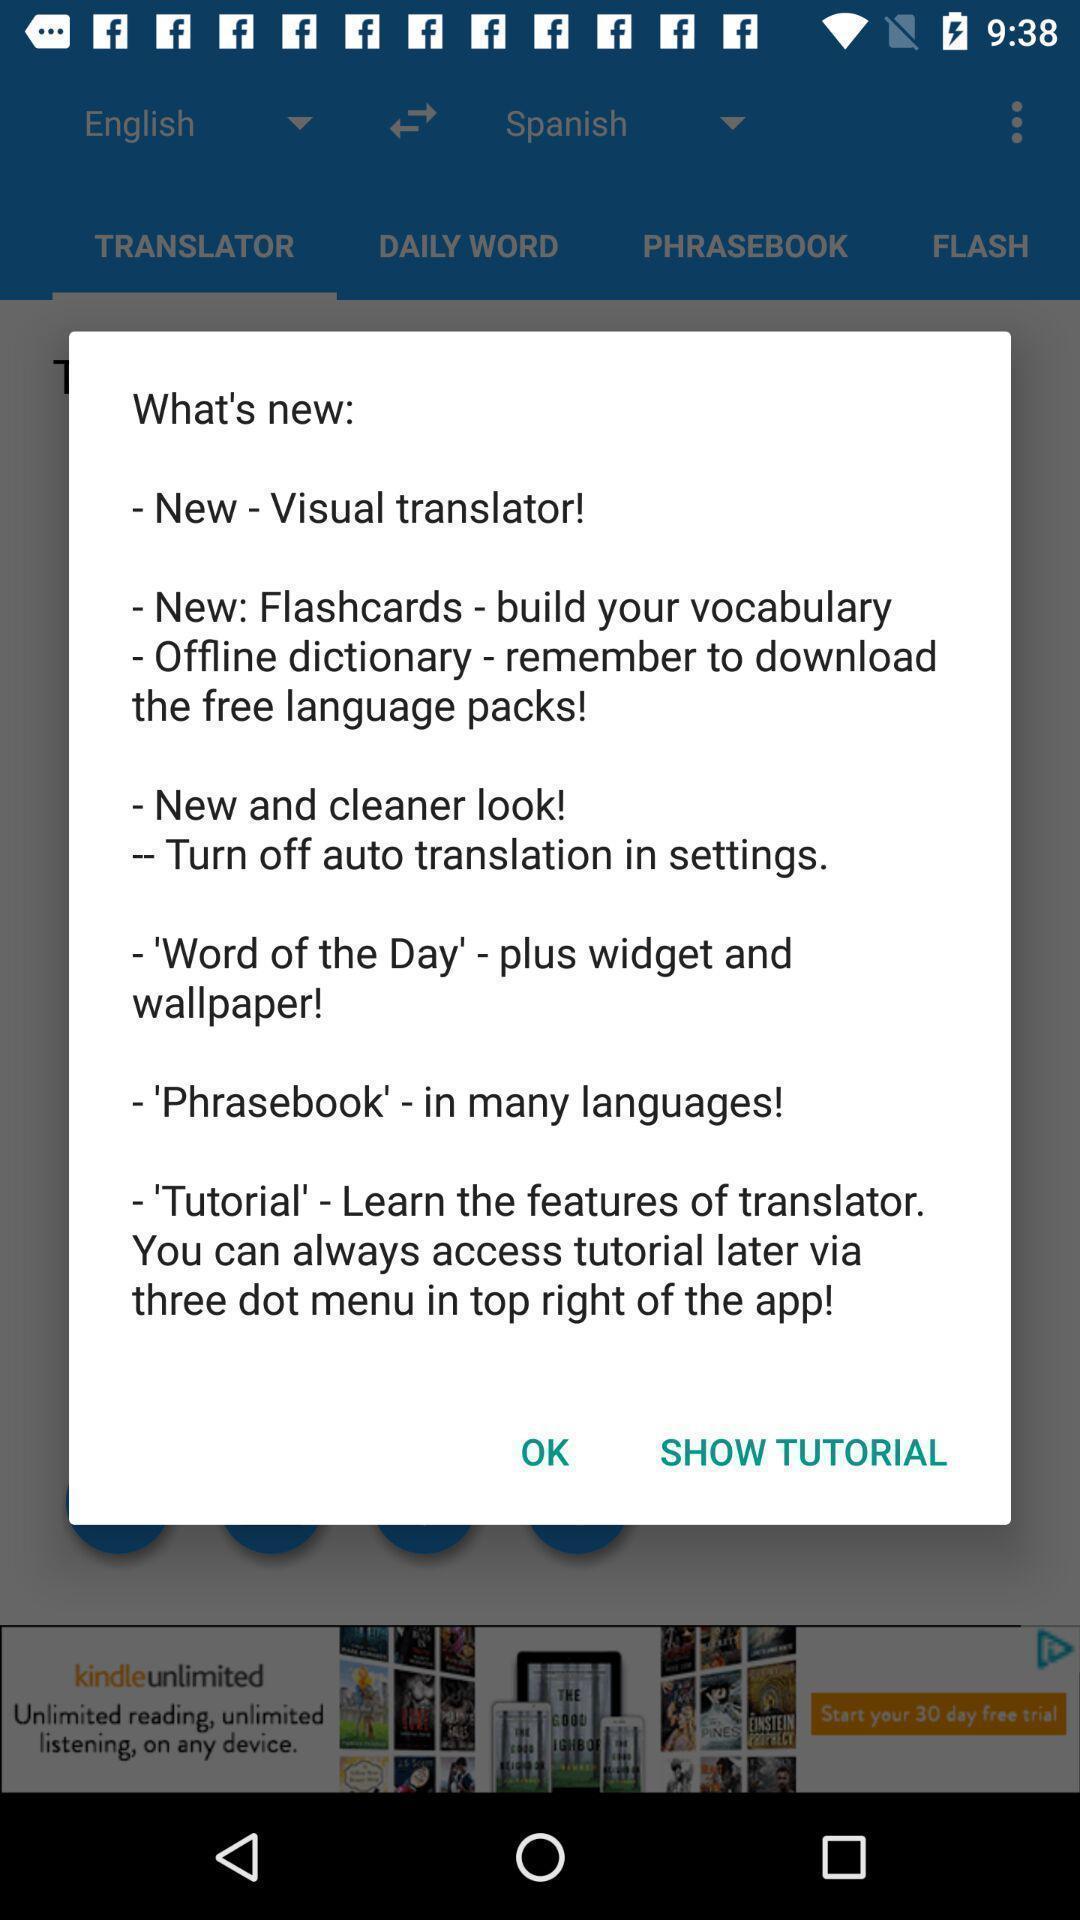Provide a detailed account of this screenshot. Pop-up showing the new added features in learning app. 